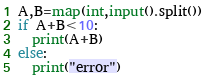Convert code to text. <code><loc_0><loc_0><loc_500><loc_500><_Python_>A,B=map(int,input().split())
if A+B<10:
  print(A+B)
else:
  print("error")</code> 